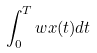Convert formula to latex. <formula><loc_0><loc_0><loc_500><loc_500>\int _ { 0 } ^ { T } w x ( t ) d t</formula> 